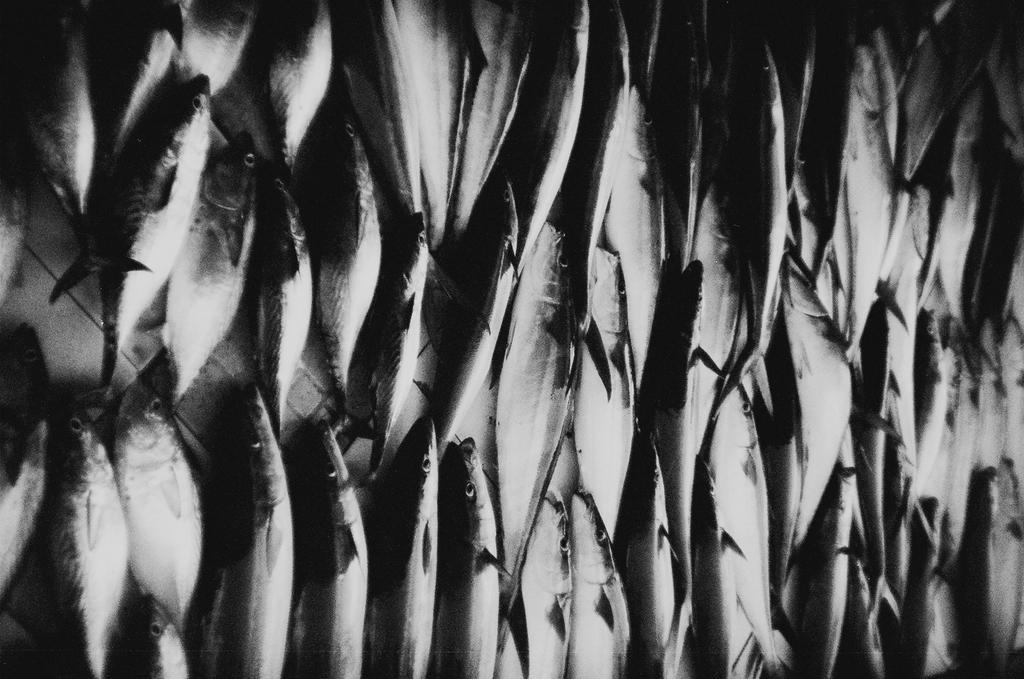How would you summarize this image in a sentence or two? This is a zoomed in picture and we can see there are many number of fishes seems to be placed on the ground. 